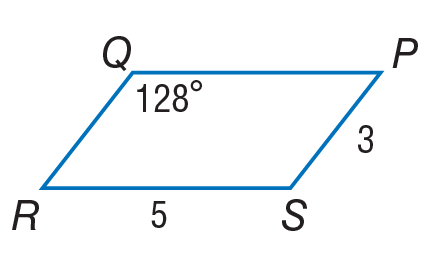Answer the mathemtical geometry problem and directly provide the correct option letter.
Question: Use parallelogram P Q R S to find m \angle R.
Choices: A: 3 B: 5 C: 52 D: 128 C 